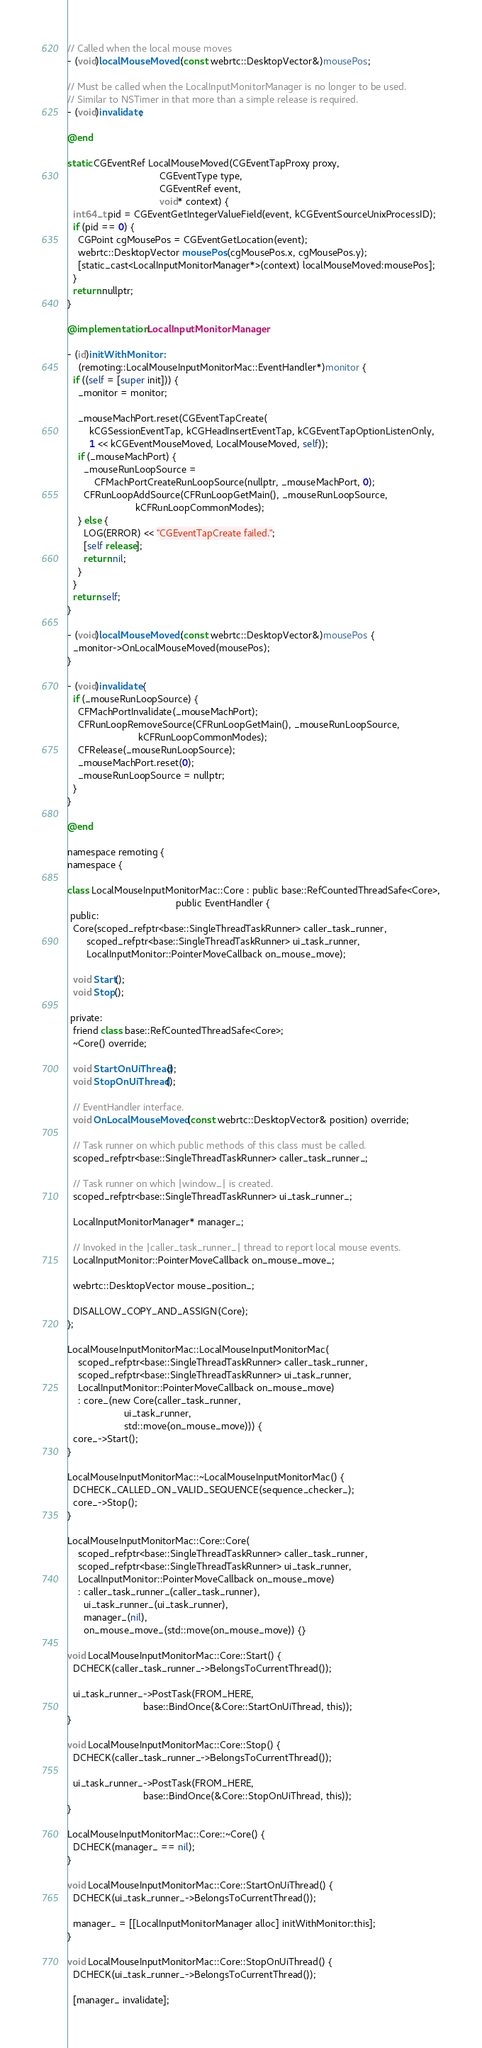Convert code to text. <code><loc_0><loc_0><loc_500><loc_500><_ObjectiveC_>// Called when the local mouse moves
- (void)localMouseMoved:(const webrtc::DesktopVector&)mousePos;

// Must be called when the LocalInputMonitorManager is no longer to be used.
// Similar to NSTimer in that more than a simple release is required.
- (void)invalidate;

@end

static CGEventRef LocalMouseMoved(CGEventTapProxy proxy,
                                  CGEventType type,
                                  CGEventRef event,
                                  void* context) {
  int64_t pid = CGEventGetIntegerValueField(event, kCGEventSourceUnixProcessID);
  if (pid == 0) {
    CGPoint cgMousePos = CGEventGetLocation(event);
    webrtc::DesktopVector mousePos(cgMousePos.x, cgMousePos.y);
    [static_cast<LocalInputMonitorManager*>(context) localMouseMoved:mousePos];
  }
  return nullptr;
}

@implementation LocalInputMonitorManager

- (id)initWithMonitor:
    (remoting::LocalMouseInputMonitorMac::EventHandler*)monitor {
  if ((self = [super init])) {
    _monitor = monitor;

    _mouseMachPort.reset(CGEventTapCreate(
        kCGSessionEventTap, kCGHeadInsertEventTap, kCGEventTapOptionListenOnly,
        1 << kCGEventMouseMoved, LocalMouseMoved, self));
    if (_mouseMachPort) {
      _mouseRunLoopSource =
          CFMachPortCreateRunLoopSource(nullptr, _mouseMachPort, 0);
      CFRunLoopAddSource(CFRunLoopGetMain(), _mouseRunLoopSource,
                         kCFRunLoopCommonModes);
    } else {
      LOG(ERROR) << "CGEventTapCreate failed.";
      [self release];
      return nil;
    }
  }
  return self;
}

- (void)localMouseMoved:(const webrtc::DesktopVector&)mousePos {
  _monitor->OnLocalMouseMoved(mousePos);
}

- (void)invalidate {
  if (_mouseRunLoopSource) {
    CFMachPortInvalidate(_mouseMachPort);
    CFRunLoopRemoveSource(CFRunLoopGetMain(), _mouseRunLoopSource,
                          kCFRunLoopCommonModes);
    CFRelease(_mouseRunLoopSource);
    _mouseMachPort.reset(0);
    _mouseRunLoopSource = nullptr;
  }
}

@end

namespace remoting {
namespace {

class LocalMouseInputMonitorMac::Core : public base::RefCountedThreadSafe<Core>,
                                        public EventHandler {
 public:
  Core(scoped_refptr<base::SingleThreadTaskRunner> caller_task_runner,
       scoped_refptr<base::SingleThreadTaskRunner> ui_task_runner,
       LocalInputMonitor::PointerMoveCallback on_mouse_move);

  void Start();
  void Stop();

 private:
  friend class base::RefCountedThreadSafe<Core>;
  ~Core() override;

  void StartOnUiThread();
  void StopOnUiThread();

  // EventHandler interface.
  void OnLocalMouseMoved(const webrtc::DesktopVector& position) override;

  // Task runner on which public methods of this class must be called.
  scoped_refptr<base::SingleThreadTaskRunner> caller_task_runner_;

  // Task runner on which |window_| is created.
  scoped_refptr<base::SingleThreadTaskRunner> ui_task_runner_;

  LocalInputMonitorManager* manager_;

  // Invoked in the |caller_task_runner_| thread to report local mouse events.
  LocalInputMonitor::PointerMoveCallback on_mouse_move_;

  webrtc::DesktopVector mouse_position_;

  DISALLOW_COPY_AND_ASSIGN(Core);
};

LocalMouseInputMonitorMac::LocalMouseInputMonitorMac(
    scoped_refptr<base::SingleThreadTaskRunner> caller_task_runner,
    scoped_refptr<base::SingleThreadTaskRunner> ui_task_runner,
    LocalInputMonitor::PointerMoveCallback on_mouse_move)
    : core_(new Core(caller_task_runner,
                     ui_task_runner,
                     std::move(on_mouse_move))) {
  core_->Start();
}

LocalMouseInputMonitorMac::~LocalMouseInputMonitorMac() {
  DCHECK_CALLED_ON_VALID_SEQUENCE(sequence_checker_);
  core_->Stop();
}

LocalMouseInputMonitorMac::Core::Core(
    scoped_refptr<base::SingleThreadTaskRunner> caller_task_runner,
    scoped_refptr<base::SingleThreadTaskRunner> ui_task_runner,
    LocalInputMonitor::PointerMoveCallback on_mouse_move)
    : caller_task_runner_(caller_task_runner),
      ui_task_runner_(ui_task_runner),
      manager_(nil),
      on_mouse_move_(std::move(on_mouse_move)) {}

void LocalMouseInputMonitorMac::Core::Start() {
  DCHECK(caller_task_runner_->BelongsToCurrentThread());

  ui_task_runner_->PostTask(FROM_HERE,
                            base::BindOnce(&Core::StartOnUiThread, this));
}

void LocalMouseInputMonitorMac::Core::Stop() {
  DCHECK(caller_task_runner_->BelongsToCurrentThread());

  ui_task_runner_->PostTask(FROM_HERE,
                            base::BindOnce(&Core::StopOnUiThread, this));
}

LocalMouseInputMonitorMac::Core::~Core() {
  DCHECK(manager_ == nil);
}

void LocalMouseInputMonitorMac::Core::StartOnUiThread() {
  DCHECK(ui_task_runner_->BelongsToCurrentThread());

  manager_ = [[LocalInputMonitorManager alloc] initWithMonitor:this];
}

void LocalMouseInputMonitorMac::Core::StopOnUiThread() {
  DCHECK(ui_task_runner_->BelongsToCurrentThread());

  [manager_ invalidate];</code> 